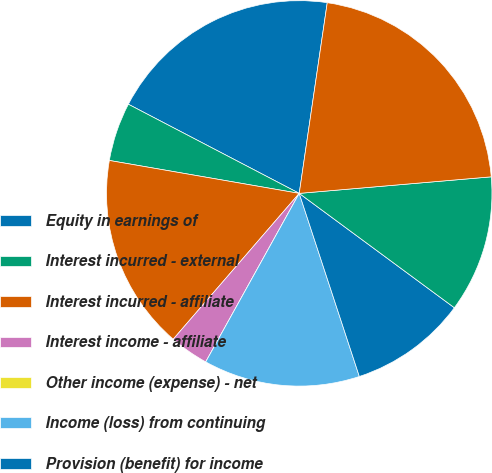<chart> <loc_0><loc_0><loc_500><loc_500><pie_chart><fcel>Equity in earnings of<fcel>Interest incurred - external<fcel>Interest incurred - affiliate<fcel>Interest income - affiliate<fcel>Other income (expense) - net<fcel>Income (loss) from continuing<fcel>Provision (benefit) for income<fcel>Net income (loss)<fcel>Weighted-average shares<nl><fcel>19.67%<fcel>4.92%<fcel>16.39%<fcel>3.28%<fcel>0.0%<fcel>13.11%<fcel>9.84%<fcel>11.48%<fcel>21.31%<nl></chart> 